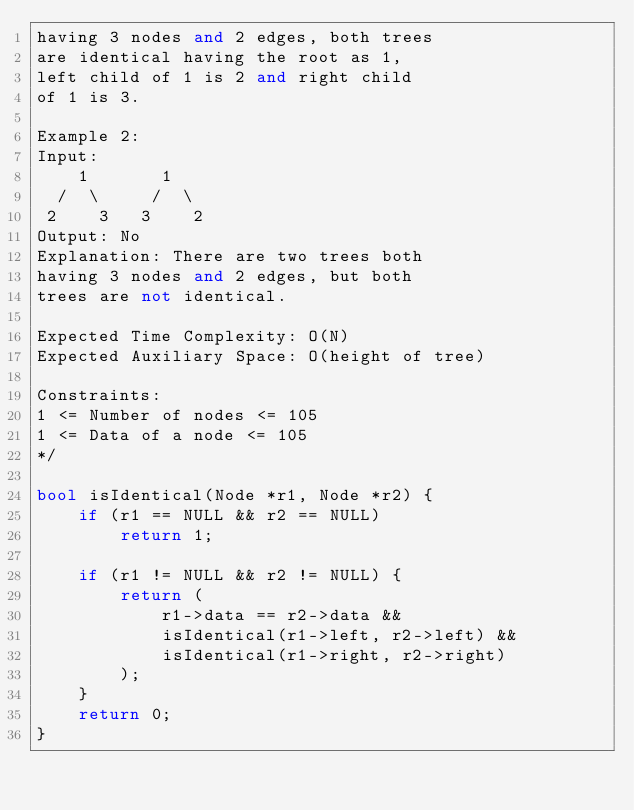<code> <loc_0><loc_0><loc_500><loc_500><_C++_>having 3 nodes and 2 edges, both trees
are identical having the root as 1,
left child of 1 is 2 and right child
of 1 is 3.

Example 2:
Input:
    1       1
  /  \     /  \
 2    3   3    2
Output: No
Explanation: There are two trees both
having 3 nodes and 2 edges, but both
trees are not identical.

Expected Time Complexity: O(N)
Expected Auxiliary Space: O(height of tree)

Constraints:
1 <= Number of nodes <= 105
1 <= Data of a node <= 105
*/

bool isIdentical(Node *r1, Node *r2) {
    if (r1 == NULL && r2 == NULL)
        return 1;
    
    if (r1 != NULL && r2 != NULL) {
        return (
            r1->data == r2->data &&
            isIdentical(r1->left, r2->left) &&
            isIdentical(r1->right, r2->right)
        );
    }
    return 0;
}</code> 